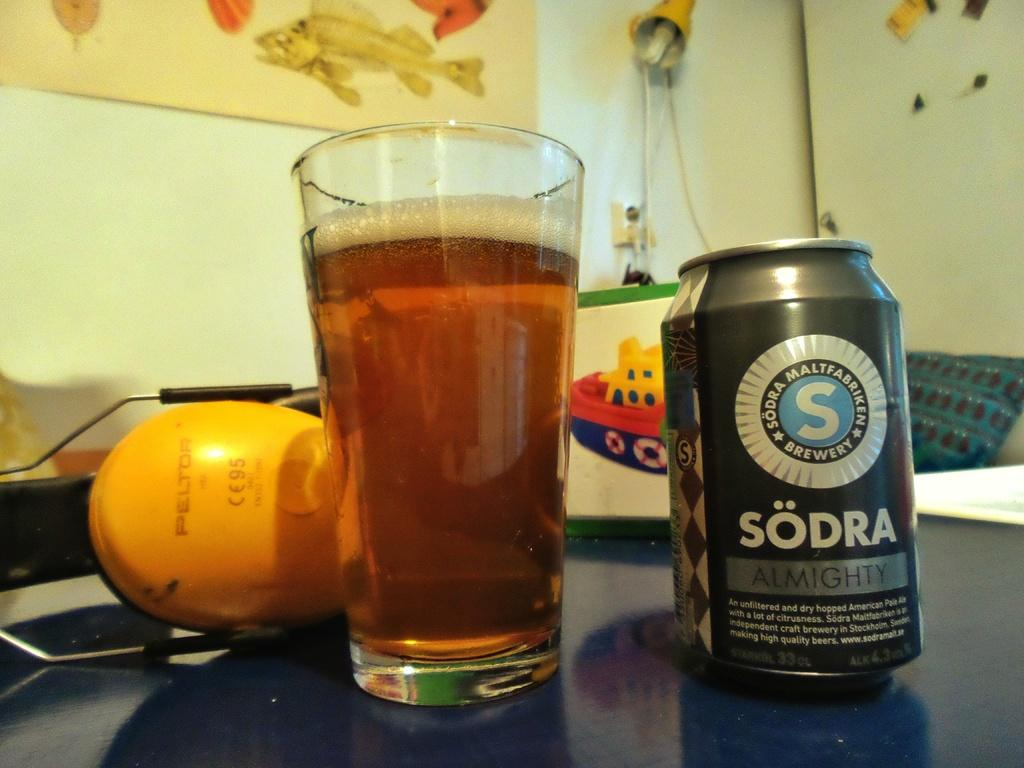Provide a one-sentence caption for the provided image. A ALUMINUM CAN CONTAINING SODRA ALMIGHTY SODA AND GLASS. 